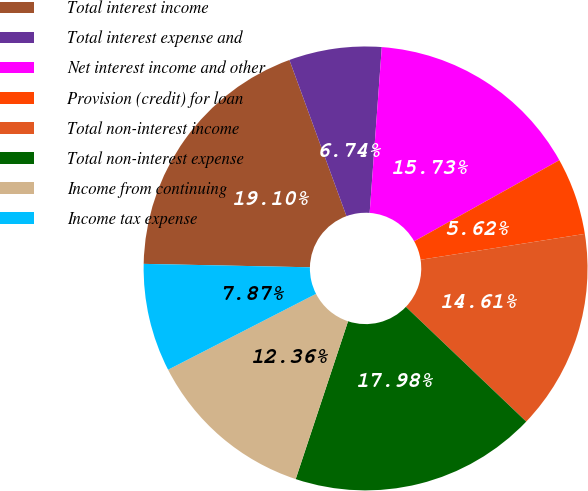Convert chart. <chart><loc_0><loc_0><loc_500><loc_500><pie_chart><fcel>Total interest income<fcel>Total interest expense and<fcel>Net interest income and other<fcel>Provision (credit) for loan<fcel>Total non-interest income<fcel>Total non-interest expense<fcel>Income from continuing<fcel>Income tax expense<nl><fcel>19.1%<fcel>6.74%<fcel>15.73%<fcel>5.62%<fcel>14.61%<fcel>17.98%<fcel>12.36%<fcel>7.87%<nl></chart> 